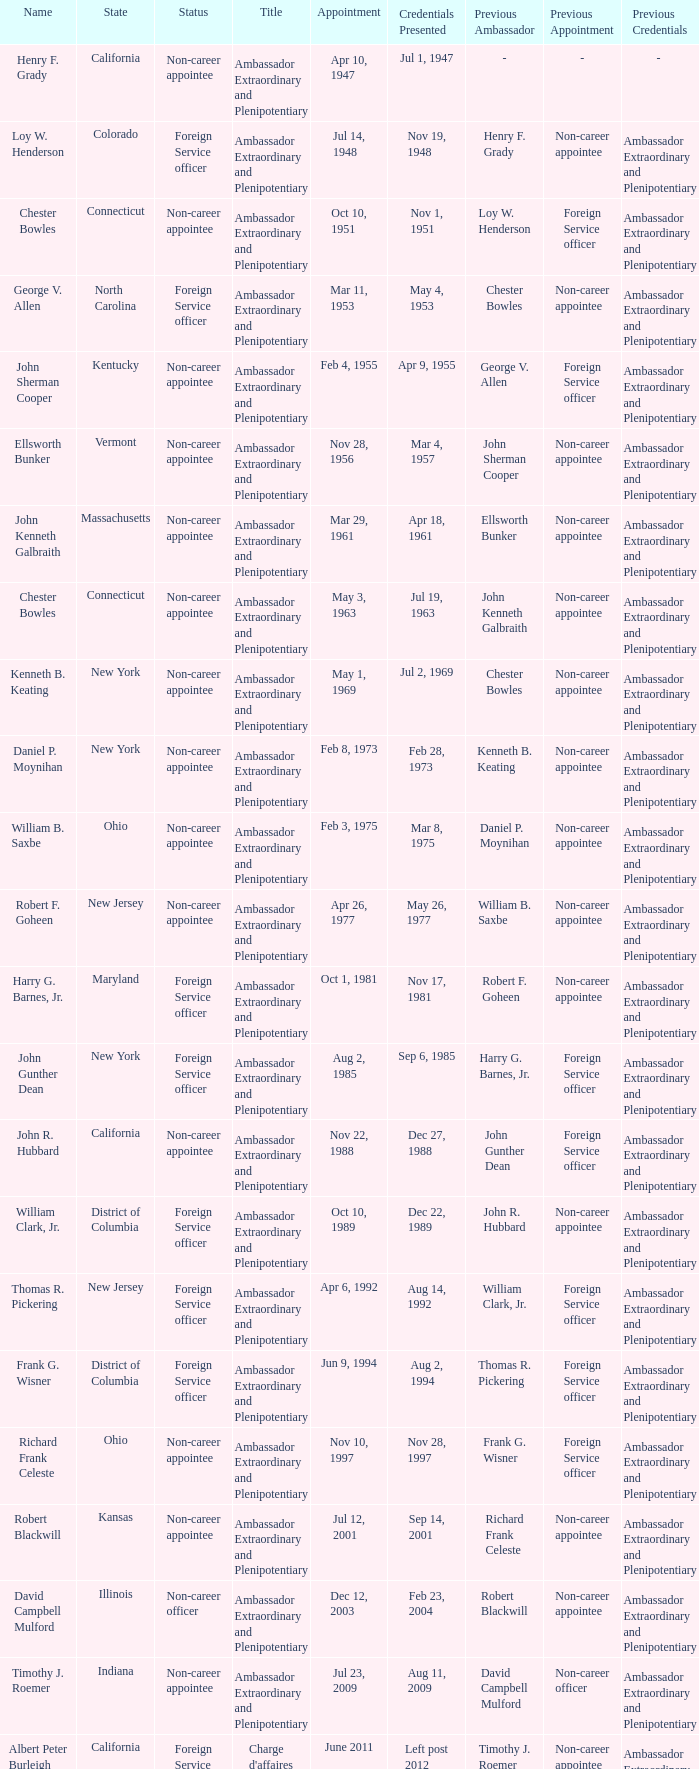What day was the appointment when Credentials Presented was jul 2, 1969? May 1, 1969. 